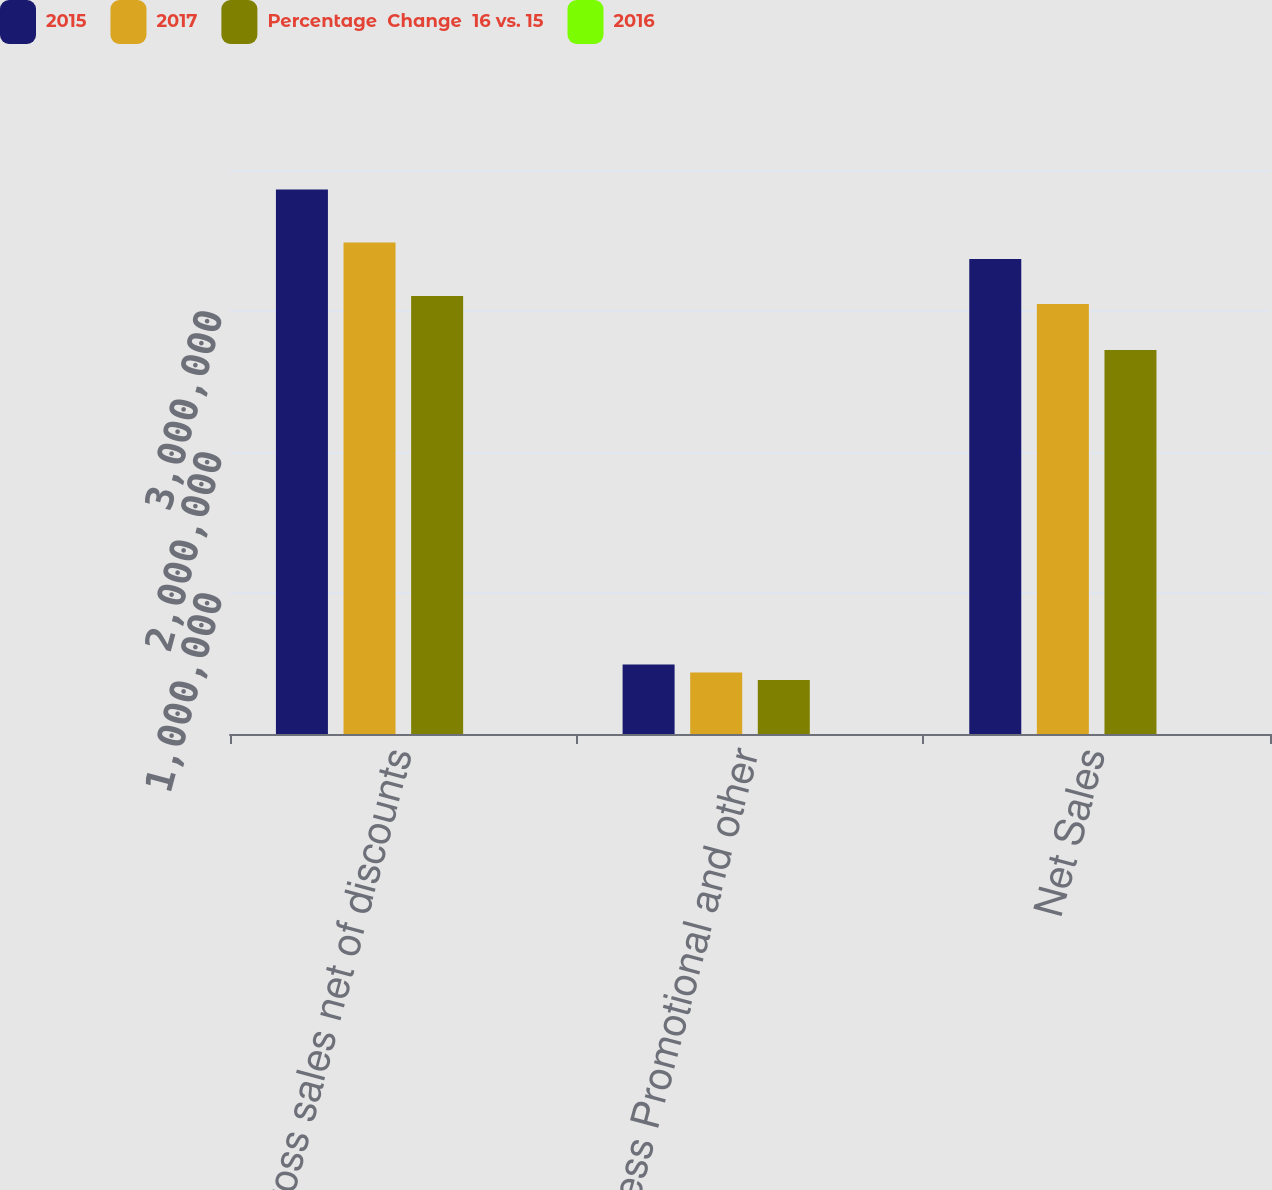<chart> <loc_0><loc_0><loc_500><loc_500><stacked_bar_chart><ecel><fcel>Gross sales net of discounts<fcel>Less Promotional and other<fcel>Net Sales<nl><fcel>2015<fcel>3.86137e+06<fcel>492323<fcel>3.36904e+06<nl><fcel>2017<fcel>3.48546e+06<fcel>436070<fcel>3.04939e+06<nl><fcel>Percentage  Change  16 vs. 15<fcel>3.10566e+06<fcel>383101<fcel>2.72256e+06<nl><fcel>2016<fcel>10.8<fcel>12.9<fcel>10.5<nl></chart> 